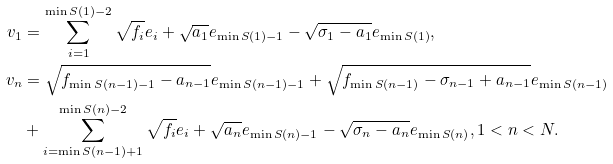<formula> <loc_0><loc_0><loc_500><loc_500>v _ { 1 } & = \sum _ { i = 1 } ^ { \min S ( 1 ) - 2 } \sqrt { f _ { i } } e _ { i } + \sqrt { a _ { 1 } } e _ { \min S ( 1 ) - 1 } - \sqrt { \sigma _ { 1 } - a _ { 1 } } e _ { \min S ( 1 ) } , \\ v _ { n } & = \sqrt { f _ { \min S ( n - 1 ) - 1 } - a _ { n - 1 } } e _ { \min S ( n - 1 ) - 1 } + \sqrt { f _ { \min S ( n - 1 ) } - \sigma _ { n - 1 } + a _ { n - 1 } } e _ { \min S ( n - 1 ) } \\ & + \sum _ { i = \min S ( n - 1 ) + 1 } ^ { \min S ( n ) - 2 } \sqrt { f _ { i } } e _ { i } + \sqrt { a _ { n } } e _ { \min S ( n ) - 1 } - \sqrt { \sigma _ { n } - a _ { n } } e _ { \min S ( n ) } , 1 < n < N .</formula> 